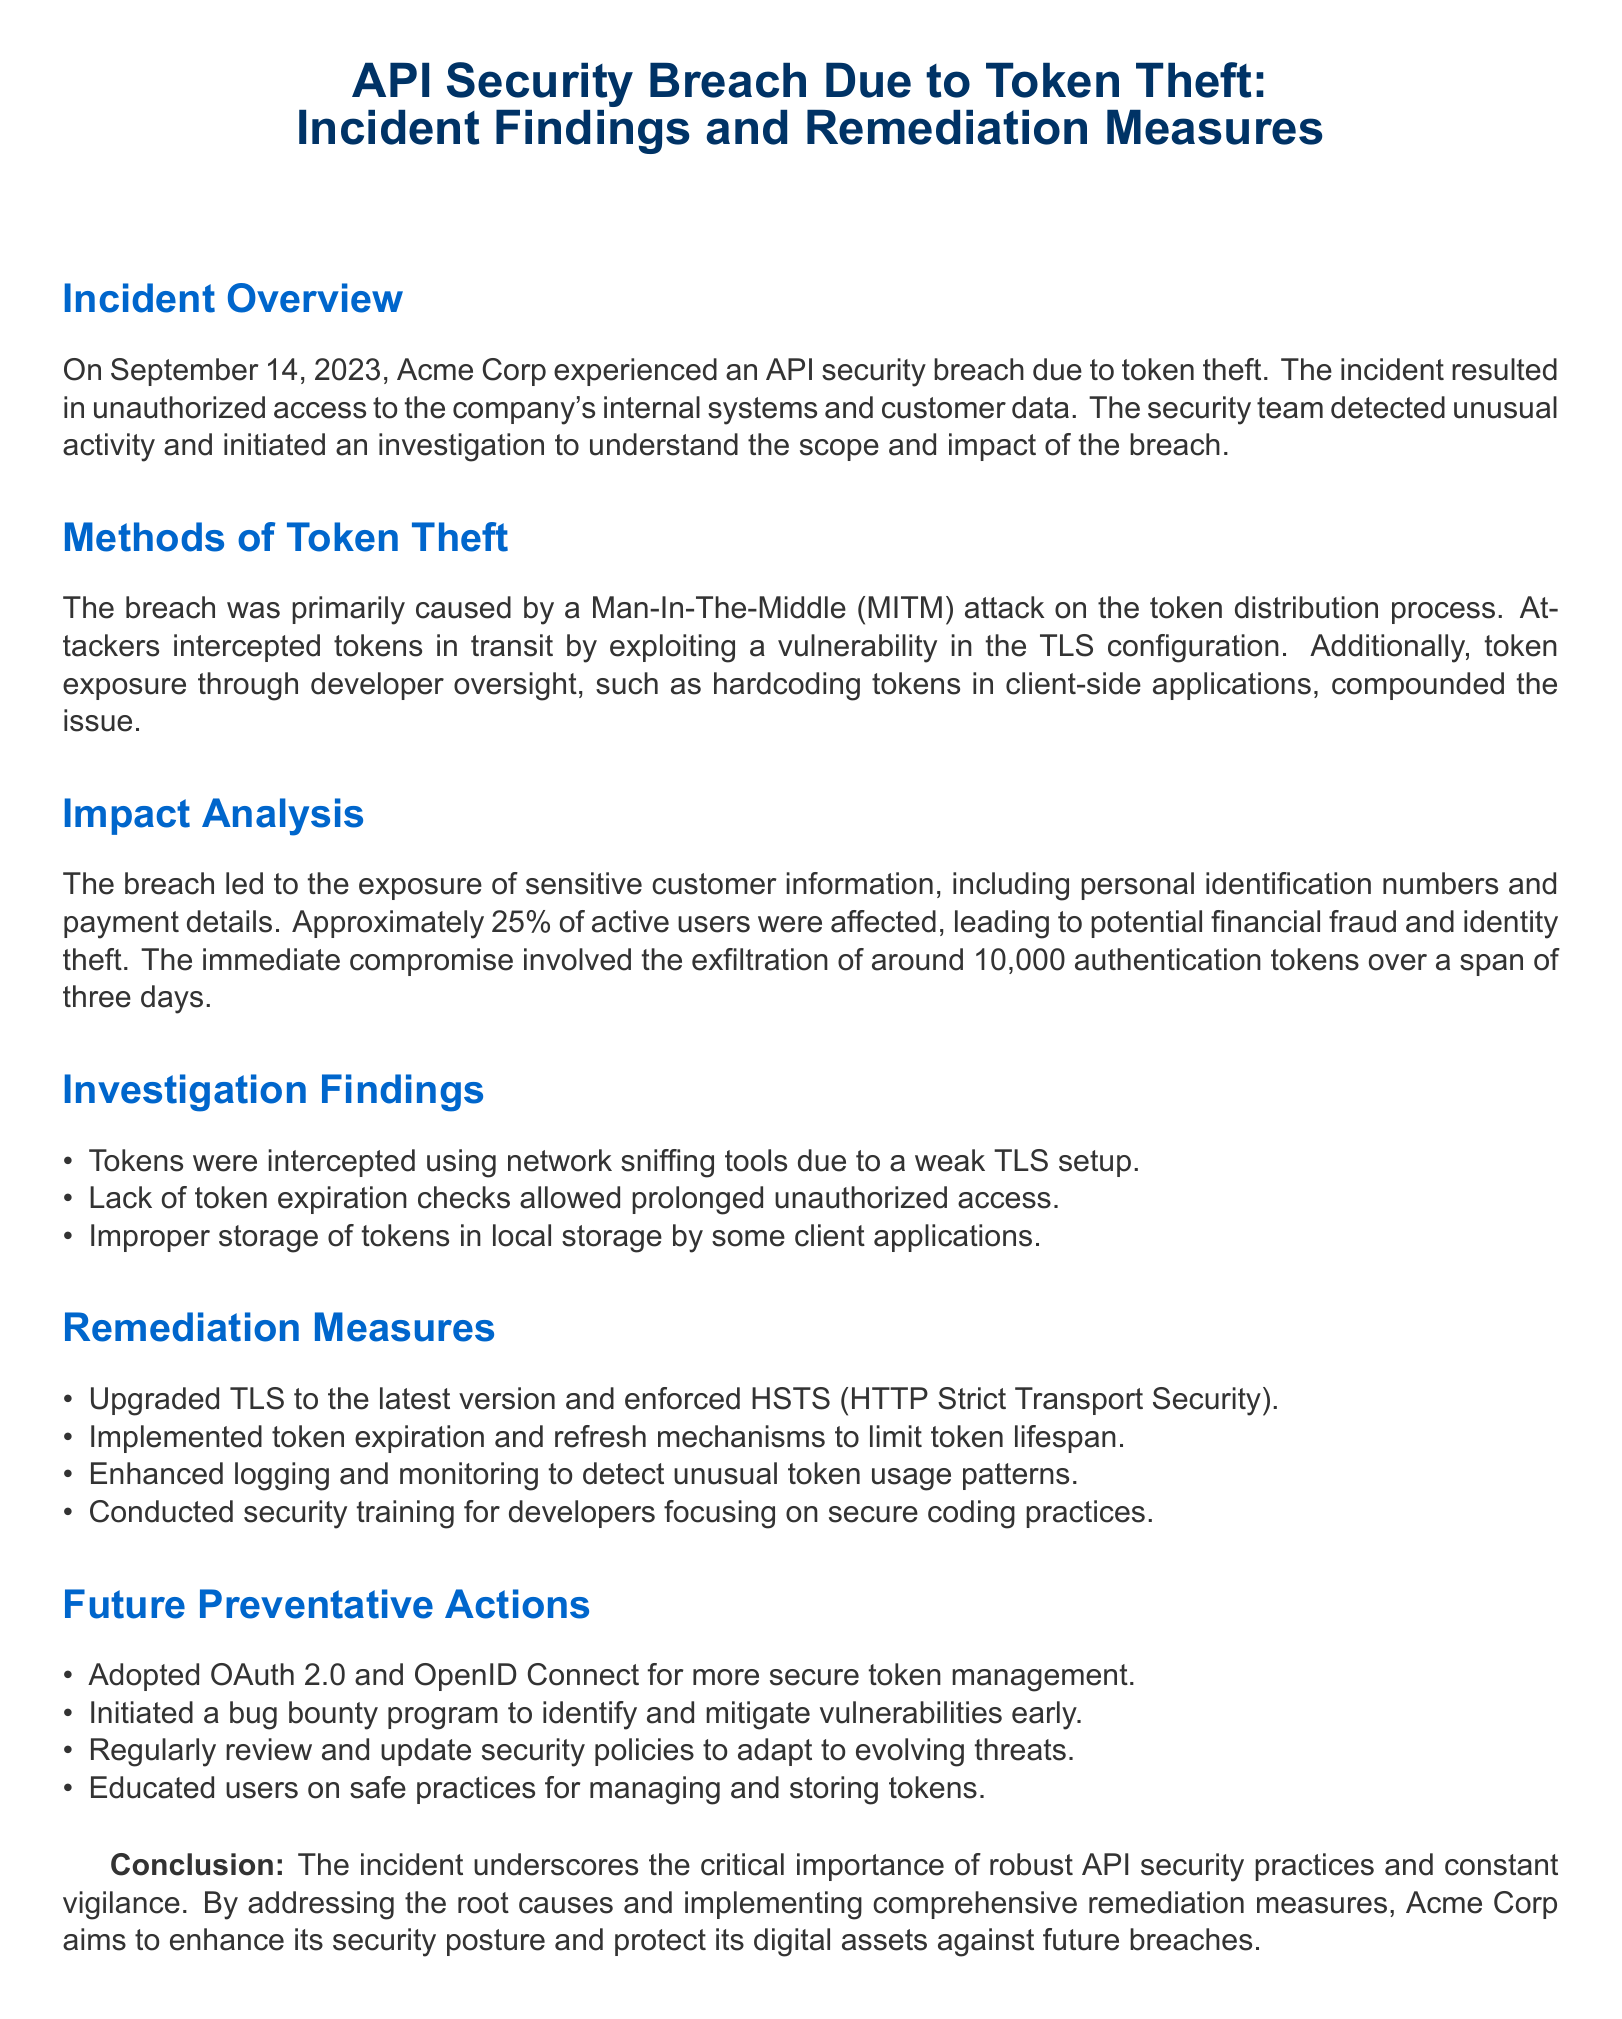What date did the breach occur? The date of the breach is clearly stated in the incident overview section, which mentions September 14, 2023.
Answer: September 14, 2023 What percentage of active users were affected? The impact analysis section specifies that approximately 25% of active users were affected by the breach.
Answer: 25% What was the main method of token theft? The methods section mentions a Man-In-The-Middle attack as the primary cause of token theft.
Answer: Man-In-The-Middle attack How many authentication tokens were exfiltrated? According to the impact analysis, it was reported that around 10,000 authentication tokens were exfiltrated.
Answer: 10,000 What remediation measure limits token lifespan? The remediation measures indicate that implementing token expiration and refresh mechanisms helps limit token lifespan.
Answer: Token expiration and refresh mechanisms What security measure was enforced to improve TLS? The remediation section states that HSTS (HTTP Strict Transport Security) was enforced as part of the TLS upgrade.
Answer: HSTS What future action is aimed at identifying vulnerabilities? The document mentions initiating a bug bounty program as a future preventative action to identify and mitigate vulnerabilities.
Answer: Bug bounty program What coding practice was emphasized in developer training? The remediation measures highlighted that developers received security training focused on secure coding practices.
Answer: Secure coding practices 